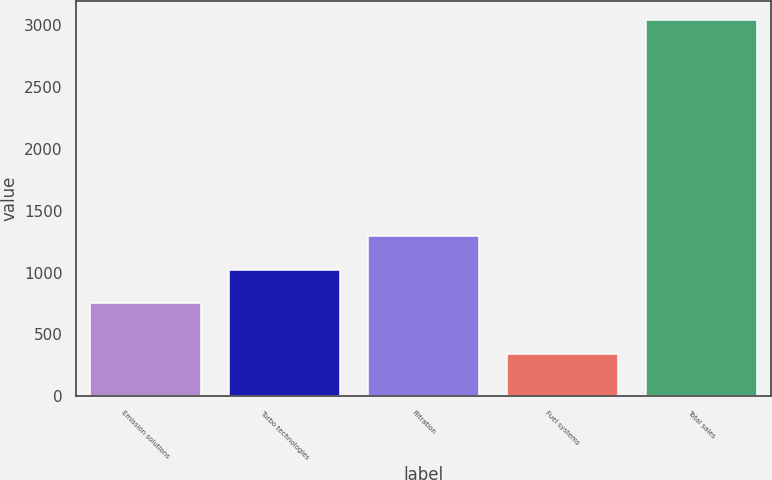<chart> <loc_0><loc_0><loc_500><loc_500><bar_chart><fcel>Emission solutions<fcel>Turbo technologies<fcel>Filtration<fcel>Fuel systems<fcel>Total sales<nl><fcel>750<fcel>1020.9<fcel>1291.8<fcel>337<fcel>3046<nl></chart> 